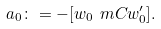Convert formula to latex. <formula><loc_0><loc_0><loc_500><loc_500>a _ { 0 } \colon = - [ w _ { 0 } \ m C w _ { 0 } ^ { \prime } ] .</formula> 